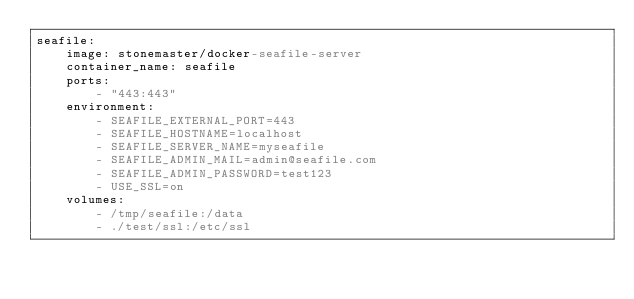<code> <loc_0><loc_0><loc_500><loc_500><_YAML_>seafile:
    image: stonemaster/docker-seafile-server
    container_name: seafile
    ports:
        - "443:443"
    environment:
        - SEAFILE_EXTERNAL_PORT=443
        - SEAFILE_HOSTNAME=localhost
        - SEAFILE_SERVER_NAME=myseafile
        - SEAFILE_ADMIN_MAIL=admin@seafile.com
        - SEAFILE_ADMIN_PASSWORD=test123
        - USE_SSL=on
    volumes:
        - /tmp/seafile:/data
        - ./test/ssl:/etc/ssl
</code> 